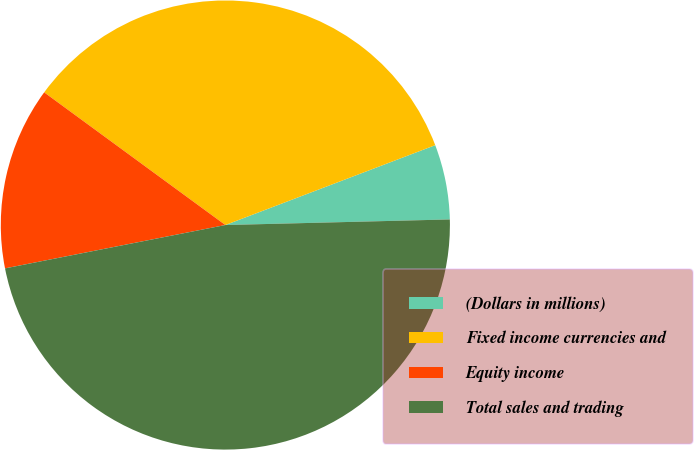Convert chart. <chart><loc_0><loc_0><loc_500><loc_500><pie_chart><fcel>(Dollars in millions)<fcel>Fixed income currencies and<fcel>Equity income<fcel>Total sales and trading<nl><fcel>5.39%<fcel>34.15%<fcel>13.15%<fcel>47.3%<nl></chart> 